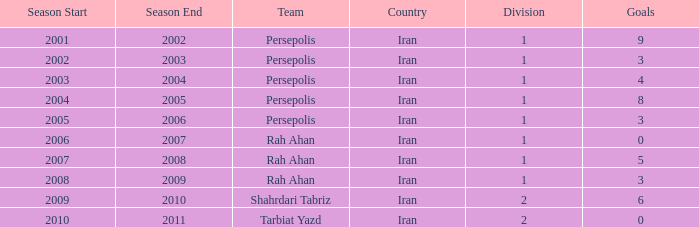What is the average Goals, when Team is "Rah Ahan", and when Division is less than 1? None. Could you parse the entire table? {'header': ['Season Start', 'Season End', 'Team', 'Country', 'Division', 'Goals'], 'rows': [['2001', '2002', 'Persepolis', 'Iran', '1', '9'], ['2002', '2003', 'Persepolis', 'Iran', '1', '3'], ['2003', '2004', 'Persepolis', 'Iran', '1', '4'], ['2004', '2005', 'Persepolis', 'Iran', '1', '8'], ['2005', '2006', 'Persepolis', 'Iran', '1', '3'], ['2006', '2007', 'Rah Ahan', 'Iran', '1', '0'], ['2007', '2008', 'Rah Ahan', 'Iran', '1', '5'], ['2008', '2009', 'Rah Ahan', 'Iran', '1', '3'], ['2009', '2010', 'Shahrdari Tabriz', 'Iran', '2', '6'], ['2010', '2011', 'Tarbiat Yazd', 'Iran', '2', '0']]} 